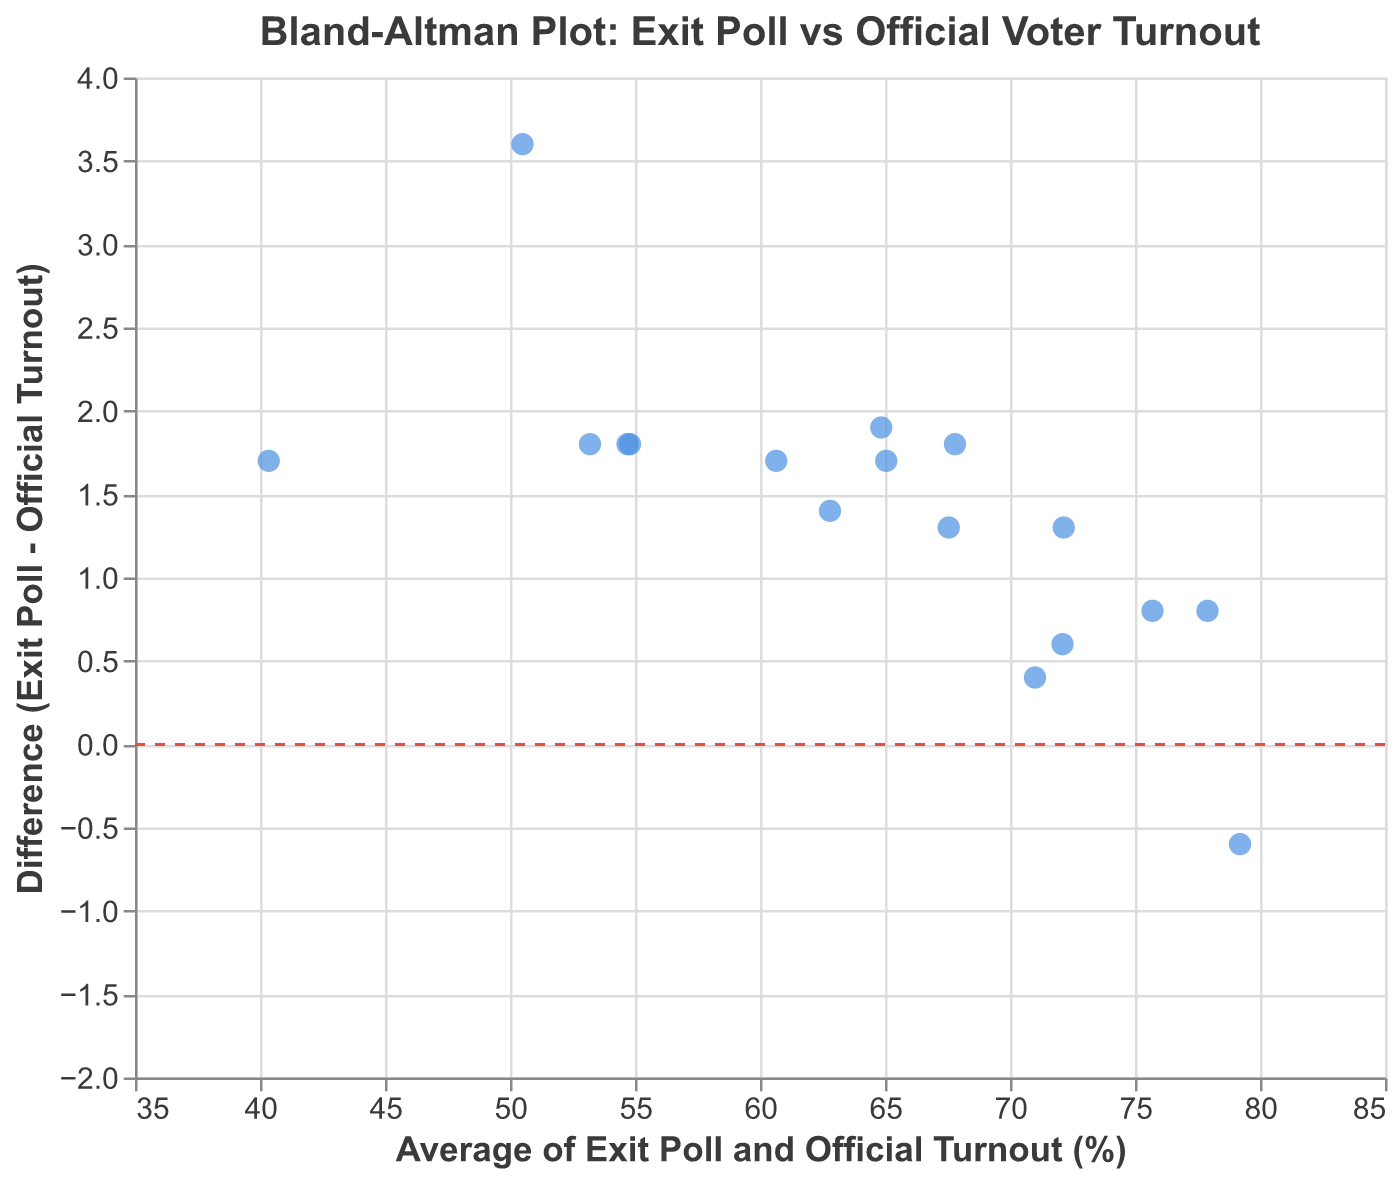What's the title of the plot? The title is displayed at the top of the figure in larger and bold font compared to the other text elements. It reads "Bland-Altman Plot: Exit Poll vs Official Voter Turnout."
Answer: Bland-Altman Plot: Exit Poll vs Official Voter Turnout What does the x-axis represent? The x-axis is labeled "Average of Exit Poll and Official Turnout (%)". Therefore, it shows the average value between exit poll turnout and official turnout.
Answer: Average of Exit Poll and Official Turnout (%) What does the y-axis represent? The y-axis is labeled "Difference (Exit Poll - Official Turnout)". This indicates that it shows the difference between the exit poll turnout and the official turnout.
Answer: Difference (Exit Poll - Official Turnout) How many demographic groups are plotted? By counting the number of points (circles) displayed on the plot, we can determine the number of demographic groups represented.
Answer: 17 Which demographic has the highest average turnout? By observing the x-axis and finding the point farthest to the right, you can find the demographic with the highest average turnout. In this case, it's "65+ years old".
Answer: 65+ years old Which demographic has the largest positive difference between exit poll and official turnout? To find this, look for the highest point on the y-axis. Here, "Rural" has the largest positive difference.
Answer: Rural Are there any demographics where the official turnout is higher than the exit poll turnout? This is indicated by points below the y-axis line at zero. "65+ years old" is a demographic where the official turnout is higher (point slightly below the zero line).
Answer: Yes What is the average turnout for the "18-24 years old" demographic, and what is its corresponding difference? From the tooltip or by identifying the point, we can see that the average turnout (x-value) and difference (y-value) for "18-24 years old" are 50.5 and 3.6, respectively.
Answer: 50.5, 3.6 Which demographic has the smallest difference between exit poll and official turnout? Locate the point closest to the zero line on the y-axis. The demographic with the smallest difference is "White non-Hispanic."
Answer: White non-Hispanic What can be inferred if most points are above or below the y=0 line? If most points are above the y=0 line, it means that the exit poll turnout generally overestimates the official turnout. Alternatively, if most points are below, it underestimates. By observing the plot, most points seem to be slightly above the line.
Answer: Exit polls slightly overestimate official turnout 